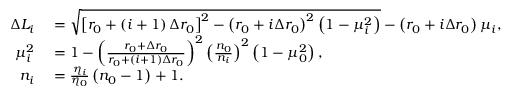Convert formula to latex. <formula><loc_0><loc_0><loc_500><loc_500>\begin{array} { r l } { \Delta L _ { i } } & = \sqrt { \left [ r _ { 0 } + \left ( i + 1 \right ) \Delta r _ { 0 } \right ] ^ { 2 } - \left ( r _ { 0 } + i \Delta r _ { 0 } \right ) ^ { 2 } \left ( 1 - \mu _ { i } ^ { 2 } \right ) } - \left ( r _ { 0 } + i \Delta r _ { 0 } \right ) \mu _ { i } , } \\ { \mu _ { i } ^ { 2 } } & = 1 - \left ( \frac { r _ { 0 } + \Delta r _ { 0 } } { r _ { 0 } + \left ( i + 1 \right ) \Delta r _ { 0 } } \right ) ^ { 2 } \left ( \frac { n _ { 0 } } { n _ { i } } \right ) ^ { 2 } \left ( 1 - \mu _ { 0 } ^ { 2 } \right ) , } \\ { n _ { i } } & = \frac { \eta _ { i } } { \eta _ { 0 } } \left ( n _ { 0 } - 1 \right ) + 1 . } \end{array}</formula> 